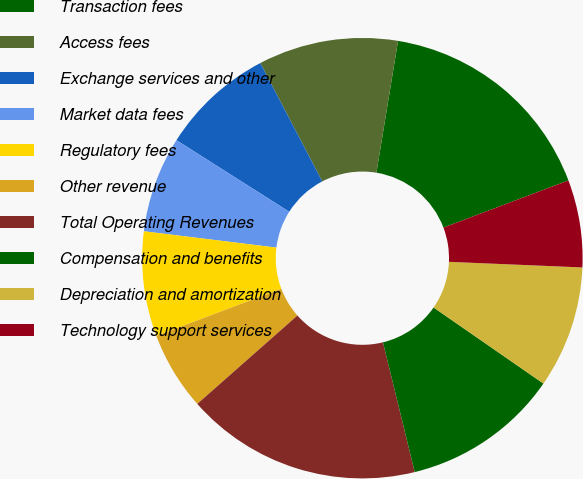<chart> <loc_0><loc_0><loc_500><loc_500><pie_chart><fcel>Transaction fees<fcel>Access fees<fcel>Exchange services and other<fcel>Market data fees<fcel>Regulatory fees<fcel>Other revenue<fcel>Total Operating Revenues<fcel>Compensation and benefits<fcel>Depreciation and amortization<fcel>Technology support services<nl><fcel>16.67%<fcel>10.26%<fcel>8.33%<fcel>7.05%<fcel>7.69%<fcel>5.77%<fcel>17.31%<fcel>11.54%<fcel>8.97%<fcel>6.41%<nl></chart> 